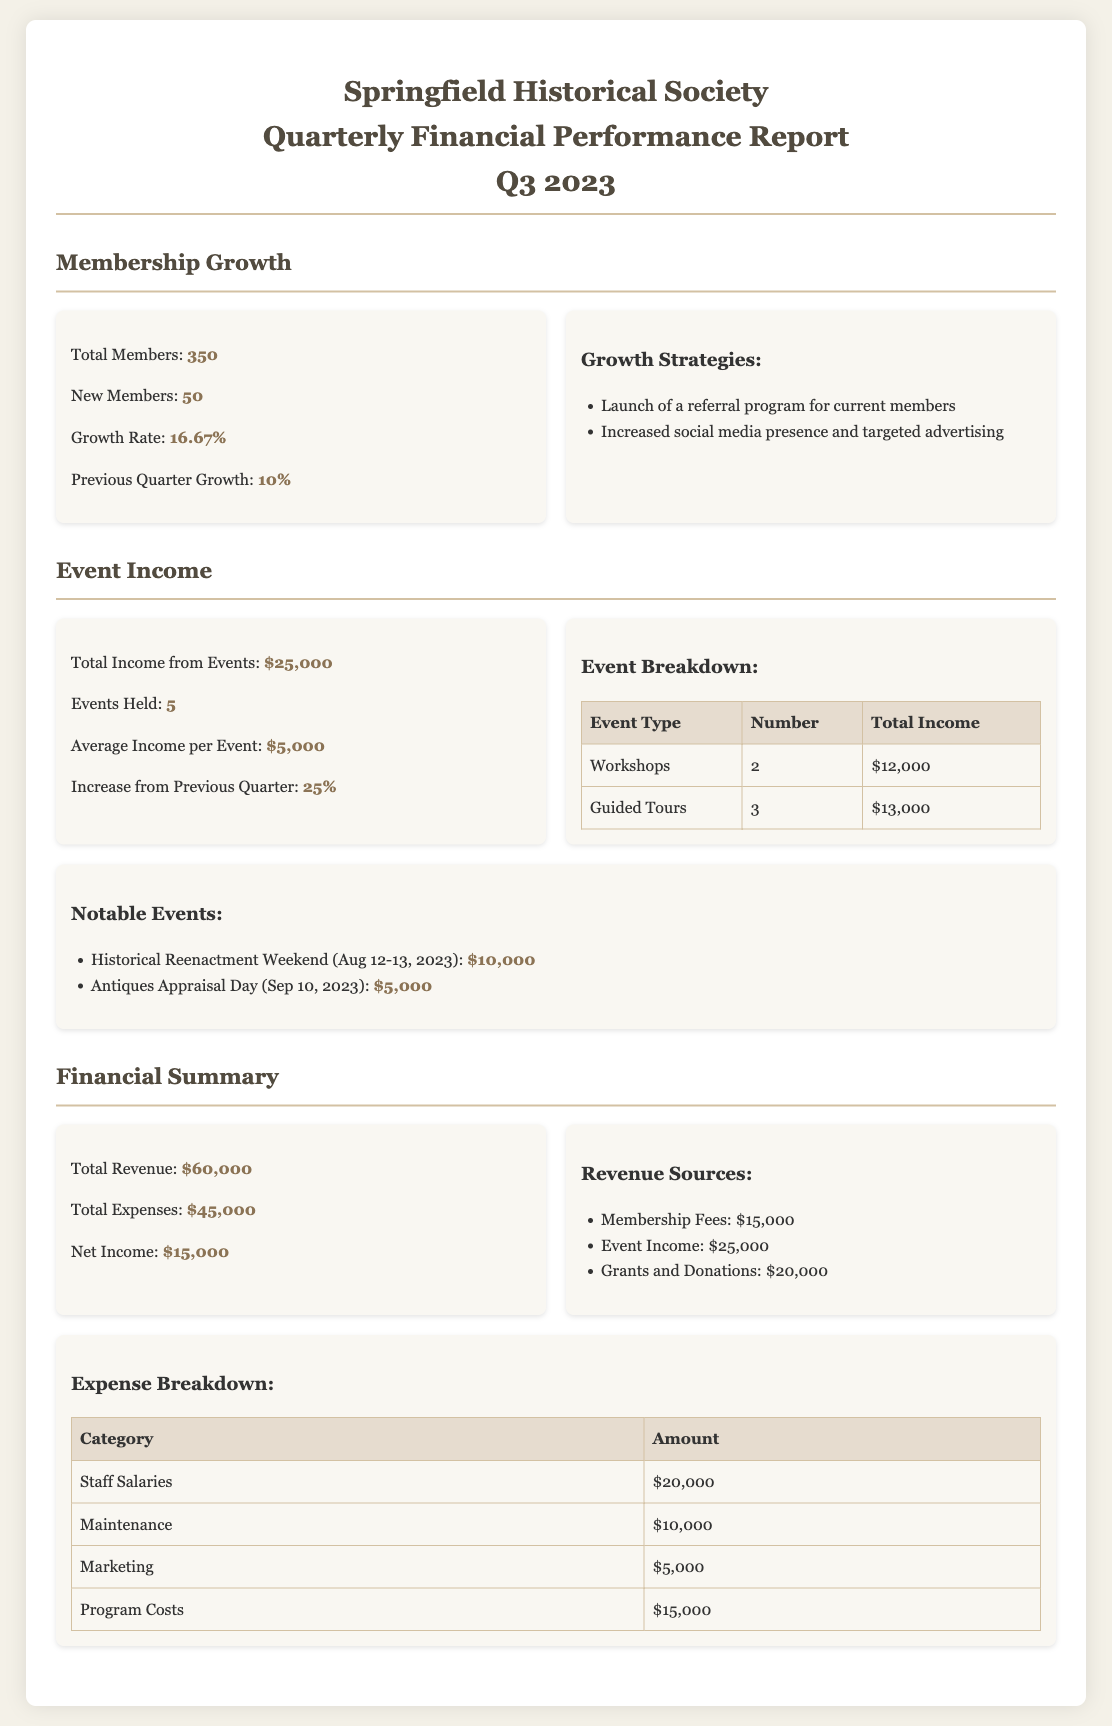What is the total number of members? The document states that the total number of members is 350.
Answer: 350 What is the membership growth rate for Q3 2023? The growth rate for Q3 2023 is directly stated in the document as 16.67%.
Answer: 16.67% How much total income did the society earn from events? The total income from events is clearly mentioned in the document as $25,000.
Answer: $25,000 How many events were held during Q3 2023? The document specifies that 5 events were held in Q3 2023.
Answer: 5 What was the notable income from the Historical Reenactment Weekend? The income from the Historical Reenactment Weekend is indicated as $10,000.
Answer: $10,000 What was the total revenue reported for Q3 2023? The total revenue is provided as $60,000 in the financial summary.
Answer: $60,000 Which revenue source contributed the most? The document lists grants and donations as the highest revenue source at $20,000.
Answer: Grants and Donations What is the total amount spent on staff salaries? The document indicates that the amount spent on staff salaries is $20,000.
Answer: $20,000 What percentage increase in event income occurred from the previous quarter? The document states that the increase from the previous quarter was 25%.
Answer: 25% 